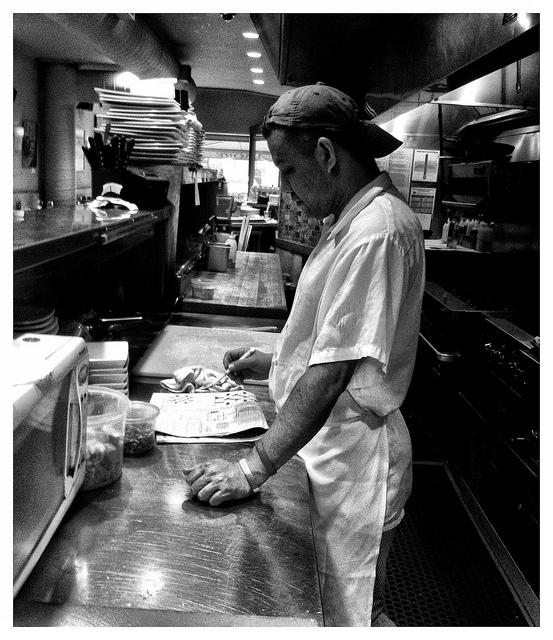What is this person's likely job title? Please explain your reasoning. line cook. A person is preparing food in a commercial kitchen. 